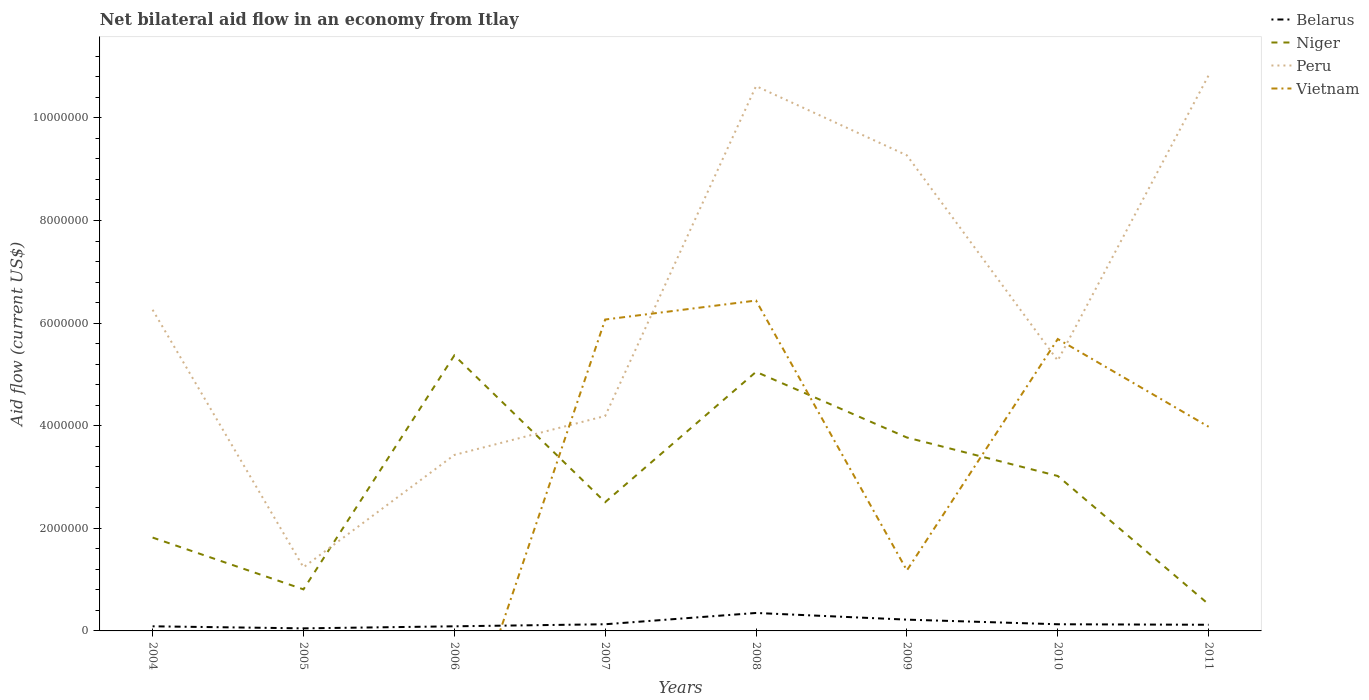How many different coloured lines are there?
Keep it short and to the point. 4. Across all years, what is the maximum net bilateral aid flow in Peru?
Your answer should be compact. 1.24e+06. What is the total net bilateral aid flow in Niger in the graph?
Give a very brief answer. -5.10e+05. What is the difference between the highest and the second highest net bilateral aid flow in Belarus?
Offer a terse response. 3.00e+05. Is the net bilateral aid flow in Peru strictly greater than the net bilateral aid flow in Belarus over the years?
Make the answer very short. No. How many years are there in the graph?
Ensure brevity in your answer.  8. What is the difference between two consecutive major ticks on the Y-axis?
Your response must be concise. 2.00e+06. Are the values on the major ticks of Y-axis written in scientific E-notation?
Provide a succinct answer. No. Does the graph contain any zero values?
Offer a very short reply. Yes. Where does the legend appear in the graph?
Give a very brief answer. Top right. How many legend labels are there?
Your response must be concise. 4. How are the legend labels stacked?
Your response must be concise. Vertical. What is the title of the graph?
Provide a short and direct response. Net bilateral aid flow in an economy from Itlay. What is the Aid flow (current US$) of Belarus in 2004?
Offer a terse response. 9.00e+04. What is the Aid flow (current US$) in Niger in 2004?
Give a very brief answer. 1.82e+06. What is the Aid flow (current US$) in Peru in 2004?
Offer a very short reply. 6.26e+06. What is the Aid flow (current US$) of Vietnam in 2004?
Offer a terse response. 0. What is the Aid flow (current US$) of Belarus in 2005?
Offer a very short reply. 5.00e+04. What is the Aid flow (current US$) in Niger in 2005?
Provide a succinct answer. 8.10e+05. What is the Aid flow (current US$) of Peru in 2005?
Make the answer very short. 1.24e+06. What is the Aid flow (current US$) in Belarus in 2006?
Provide a short and direct response. 9.00e+04. What is the Aid flow (current US$) in Niger in 2006?
Offer a very short reply. 5.37e+06. What is the Aid flow (current US$) in Peru in 2006?
Your answer should be very brief. 3.43e+06. What is the Aid flow (current US$) of Vietnam in 2006?
Provide a short and direct response. 0. What is the Aid flow (current US$) of Niger in 2007?
Keep it short and to the point. 2.51e+06. What is the Aid flow (current US$) of Peru in 2007?
Give a very brief answer. 4.19e+06. What is the Aid flow (current US$) in Vietnam in 2007?
Make the answer very short. 6.07e+06. What is the Aid flow (current US$) in Belarus in 2008?
Your answer should be compact. 3.50e+05. What is the Aid flow (current US$) in Niger in 2008?
Offer a very short reply. 5.05e+06. What is the Aid flow (current US$) in Peru in 2008?
Make the answer very short. 1.06e+07. What is the Aid flow (current US$) in Vietnam in 2008?
Ensure brevity in your answer.  6.44e+06. What is the Aid flow (current US$) of Belarus in 2009?
Your answer should be very brief. 2.20e+05. What is the Aid flow (current US$) in Niger in 2009?
Offer a terse response. 3.77e+06. What is the Aid flow (current US$) of Peru in 2009?
Your response must be concise. 9.27e+06. What is the Aid flow (current US$) in Vietnam in 2009?
Make the answer very short. 1.18e+06. What is the Aid flow (current US$) in Belarus in 2010?
Your response must be concise. 1.30e+05. What is the Aid flow (current US$) in Niger in 2010?
Give a very brief answer. 3.02e+06. What is the Aid flow (current US$) of Peru in 2010?
Your answer should be compact. 5.27e+06. What is the Aid flow (current US$) of Vietnam in 2010?
Provide a short and direct response. 5.69e+06. What is the Aid flow (current US$) in Niger in 2011?
Your response must be concise. 5.20e+05. What is the Aid flow (current US$) of Peru in 2011?
Your answer should be compact. 1.08e+07. What is the Aid flow (current US$) of Vietnam in 2011?
Your answer should be compact. 3.98e+06. Across all years, what is the maximum Aid flow (current US$) in Niger?
Your response must be concise. 5.37e+06. Across all years, what is the maximum Aid flow (current US$) in Peru?
Your response must be concise. 1.08e+07. Across all years, what is the maximum Aid flow (current US$) of Vietnam?
Make the answer very short. 6.44e+06. Across all years, what is the minimum Aid flow (current US$) in Belarus?
Keep it short and to the point. 5.00e+04. Across all years, what is the minimum Aid flow (current US$) in Niger?
Make the answer very short. 5.20e+05. Across all years, what is the minimum Aid flow (current US$) in Peru?
Your answer should be compact. 1.24e+06. Across all years, what is the minimum Aid flow (current US$) of Vietnam?
Give a very brief answer. 0. What is the total Aid flow (current US$) in Belarus in the graph?
Your answer should be compact. 1.18e+06. What is the total Aid flow (current US$) of Niger in the graph?
Offer a very short reply. 2.29e+07. What is the total Aid flow (current US$) of Peru in the graph?
Give a very brief answer. 5.11e+07. What is the total Aid flow (current US$) in Vietnam in the graph?
Your answer should be very brief. 2.34e+07. What is the difference between the Aid flow (current US$) of Belarus in 2004 and that in 2005?
Your answer should be very brief. 4.00e+04. What is the difference between the Aid flow (current US$) in Niger in 2004 and that in 2005?
Your answer should be very brief. 1.01e+06. What is the difference between the Aid flow (current US$) of Peru in 2004 and that in 2005?
Keep it short and to the point. 5.02e+06. What is the difference between the Aid flow (current US$) in Belarus in 2004 and that in 2006?
Offer a terse response. 0. What is the difference between the Aid flow (current US$) in Niger in 2004 and that in 2006?
Provide a succinct answer. -3.55e+06. What is the difference between the Aid flow (current US$) of Peru in 2004 and that in 2006?
Keep it short and to the point. 2.83e+06. What is the difference between the Aid flow (current US$) of Niger in 2004 and that in 2007?
Your answer should be very brief. -6.90e+05. What is the difference between the Aid flow (current US$) of Peru in 2004 and that in 2007?
Ensure brevity in your answer.  2.07e+06. What is the difference between the Aid flow (current US$) of Belarus in 2004 and that in 2008?
Make the answer very short. -2.60e+05. What is the difference between the Aid flow (current US$) in Niger in 2004 and that in 2008?
Offer a terse response. -3.23e+06. What is the difference between the Aid flow (current US$) of Peru in 2004 and that in 2008?
Ensure brevity in your answer.  -4.36e+06. What is the difference between the Aid flow (current US$) in Niger in 2004 and that in 2009?
Offer a very short reply. -1.95e+06. What is the difference between the Aid flow (current US$) of Peru in 2004 and that in 2009?
Keep it short and to the point. -3.01e+06. What is the difference between the Aid flow (current US$) of Belarus in 2004 and that in 2010?
Give a very brief answer. -4.00e+04. What is the difference between the Aid flow (current US$) in Niger in 2004 and that in 2010?
Your answer should be very brief. -1.20e+06. What is the difference between the Aid flow (current US$) in Peru in 2004 and that in 2010?
Give a very brief answer. 9.90e+05. What is the difference between the Aid flow (current US$) in Belarus in 2004 and that in 2011?
Your answer should be very brief. -3.00e+04. What is the difference between the Aid flow (current US$) of Niger in 2004 and that in 2011?
Give a very brief answer. 1.30e+06. What is the difference between the Aid flow (current US$) of Peru in 2004 and that in 2011?
Provide a short and direct response. -4.57e+06. What is the difference between the Aid flow (current US$) in Belarus in 2005 and that in 2006?
Offer a terse response. -4.00e+04. What is the difference between the Aid flow (current US$) in Niger in 2005 and that in 2006?
Your answer should be very brief. -4.56e+06. What is the difference between the Aid flow (current US$) in Peru in 2005 and that in 2006?
Give a very brief answer. -2.19e+06. What is the difference between the Aid flow (current US$) of Niger in 2005 and that in 2007?
Keep it short and to the point. -1.70e+06. What is the difference between the Aid flow (current US$) of Peru in 2005 and that in 2007?
Your response must be concise. -2.95e+06. What is the difference between the Aid flow (current US$) of Niger in 2005 and that in 2008?
Your answer should be compact. -4.24e+06. What is the difference between the Aid flow (current US$) in Peru in 2005 and that in 2008?
Make the answer very short. -9.38e+06. What is the difference between the Aid flow (current US$) of Niger in 2005 and that in 2009?
Offer a very short reply. -2.96e+06. What is the difference between the Aid flow (current US$) in Peru in 2005 and that in 2009?
Your answer should be very brief. -8.03e+06. What is the difference between the Aid flow (current US$) in Belarus in 2005 and that in 2010?
Provide a short and direct response. -8.00e+04. What is the difference between the Aid flow (current US$) in Niger in 2005 and that in 2010?
Offer a very short reply. -2.21e+06. What is the difference between the Aid flow (current US$) in Peru in 2005 and that in 2010?
Your answer should be compact. -4.03e+06. What is the difference between the Aid flow (current US$) in Belarus in 2005 and that in 2011?
Ensure brevity in your answer.  -7.00e+04. What is the difference between the Aid flow (current US$) in Niger in 2005 and that in 2011?
Make the answer very short. 2.90e+05. What is the difference between the Aid flow (current US$) of Peru in 2005 and that in 2011?
Offer a terse response. -9.59e+06. What is the difference between the Aid flow (current US$) of Belarus in 2006 and that in 2007?
Ensure brevity in your answer.  -4.00e+04. What is the difference between the Aid flow (current US$) of Niger in 2006 and that in 2007?
Your response must be concise. 2.86e+06. What is the difference between the Aid flow (current US$) in Peru in 2006 and that in 2007?
Your answer should be very brief. -7.60e+05. What is the difference between the Aid flow (current US$) in Peru in 2006 and that in 2008?
Ensure brevity in your answer.  -7.19e+06. What is the difference between the Aid flow (current US$) of Belarus in 2006 and that in 2009?
Offer a very short reply. -1.30e+05. What is the difference between the Aid flow (current US$) in Niger in 2006 and that in 2009?
Offer a terse response. 1.60e+06. What is the difference between the Aid flow (current US$) in Peru in 2006 and that in 2009?
Provide a short and direct response. -5.84e+06. What is the difference between the Aid flow (current US$) in Niger in 2006 and that in 2010?
Your response must be concise. 2.35e+06. What is the difference between the Aid flow (current US$) of Peru in 2006 and that in 2010?
Keep it short and to the point. -1.84e+06. What is the difference between the Aid flow (current US$) in Niger in 2006 and that in 2011?
Your response must be concise. 4.85e+06. What is the difference between the Aid flow (current US$) of Peru in 2006 and that in 2011?
Keep it short and to the point. -7.40e+06. What is the difference between the Aid flow (current US$) in Belarus in 2007 and that in 2008?
Your answer should be very brief. -2.20e+05. What is the difference between the Aid flow (current US$) in Niger in 2007 and that in 2008?
Provide a short and direct response. -2.54e+06. What is the difference between the Aid flow (current US$) in Peru in 2007 and that in 2008?
Your answer should be compact. -6.43e+06. What is the difference between the Aid flow (current US$) in Vietnam in 2007 and that in 2008?
Offer a very short reply. -3.70e+05. What is the difference between the Aid flow (current US$) in Niger in 2007 and that in 2009?
Your answer should be very brief. -1.26e+06. What is the difference between the Aid flow (current US$) of Peru in 2007 and that in 2009?
Offer a very short reply. -5.08e+06. What is the difference between the Aid flow (current US$) in Vietnam in 2007 and that in 2009?
Provide a succinct answer. 4.89e+06. What is the difference between the Aid flow (current US$) in Niger in 2007 and that in 2010?
Your response must be concise. -5.10e+05. What is the difference between the Aid flow (current US$) in Peru in 2007 and that in 2010?
Provide a short and direct response. -1.08e+06. What is the difference between the Aid flow (current US$) of Vietnam in 2007 and that in 2010?
Offer a very short reply. 3.80e+05. What is the difference between the Aid flow (current US$) of Belarus in 2007 and that in 2011?
Your response must be concise. 10000. What is the difference between the Aid flow (current US$) in Niger in 2007 and that in 2011?
Provide a succinct answer. 1.99e+06. What is the difference between the Aid flow (current US$) in Peru in 2007 and that in 2011?
Your response must be concise. -6.64e+06. What is the difference between the Aid flow (current US$) of Vietnam in 2007 and that in 2011?
Make the answer very short. 2.09e+06. What is the difference between the Aid flow (current US$) of Niger in 2008 and that in 2009?
Give a very brief answer. 1.28e+06. What is the difference between the Aid flow (current US$) in Peru in 2008 and that in 2009?
Offer a very short reply. 1.35e+06. What is the difference between the Aid flow (current US$) of Vietnam in 2008 and that in 2009?
Ensure brevity in your answer.  5.26e+06. What is the difference between the Aid flow (current US$) of Belarus in 2008 and that in 2010?
Offer a terse response. 2.20e+05. What is the difference between the Aid flow (current US$) of Niger in 2008 and that in 2010?
Ensure brevity in your answer.  2.03e+06. What is the difference between the Aid flow (current US$) in Peru in 2008 and that in 2010?
Your response must be concise. 5.35e+06. What is the difference between the Aid flow (current US$) in Vietnam in 2008 and that in 2010?
Keep it short and to the point. 7.50e+05. What is the difference between the Aid flow (current US$) of Niger in 2008 and that in 2011?
Ensure brevity in your answer.  4.53e+06. What is the difference between the Aid flow (current US$) in Peru in 2008 and that in 2011?
Your answer should be very brief. -2.10e+05. What is the difference between the Aid flow (current US$) of Vietnam in 2008 and that in 2011?
Offer a very short reply. 2.46e+06. What is the difference between the Aid flow (current US$) in Belarus in 2009 and that in 2010?
Offer a very short reply. 9.00e+04. What is the difference between the Aid flow (current US$) in Niger in 2009 and that in 2010?
Your answer should be very brief. 7.50e+05. What is the difference between the Aid flow (current US$) in Peru in 2009 and that in 2010?
Keep it short and to the point. 4.00e+06. What is the difference between the Aid flow (current US$) of Vietnam in 2009 and that in 2010?
Your response must be concise. -4.51e+06. What is the difference between the Aid flow (current US$) of Belarus in 2009 and that in 2011?
Ensure brevity in your answer.  1.00e+05. What is the difference between the Aid flow (current US$) in Niger in 2009 and that in 2011?
Make the answer very short. 3.25e+06. What is the difference between the Aid flow (current US$) of Peru in 2009 and that in 2011?
Make the answer very short. -1.56e+06. What is the difference between the Aid flow (current US$) in Vietnam in 2009 and that in 2011?
Provide a short and direct response. -2.80e+06. What is the difference between the Aid flow (current US$) in Belarus in 2010 and that in 2011?
Your response must be concise. 10000. What is the difference between the Aid flow (current US$) of Niger in 2010 and that in 2011?
Give a very brief answer. 2.50e+06. What is the difference between the Aid flow (current US$) of Peru in 2010 and that in 2011?
Offer a terse response. -5.56e+06. What is the difference between the Aid flow (current US$) of Vietnam in 2010 and that in 2011?
Offer a terse response. 1.71e+06. What is the difference between the Aid flow (current US$) of Belarus in 2004 and the Aid flow (current US$) of Niger in 2005?
Provide a succinct answer. -7.20e+05. What is the difference between the Aid flow (current US$) of Belarus in 2004 and the Aid flow (current US$) of Peru in 2005?
Your answer should be very brief. -1.15e+06. What is the difference between the Aid flow (current US$) of Niger in 2004 and the Aid flow (current US$) of Peru in 2005?
Your response must be concise. 5.80e+05. What is the difference between the Aid flow (current US$) in Belarus in 2004 and the Aid flow (current US$) in Niger in 2006?
Give a very brief answer. -5.28e+06. What is the difference between the Aid flow (current US$) in Belarus in 2004 and the Aid flow (current US$) in Peru in 2006?
Provide a short and direct response. -3.34e+06. What is the difference between the Aid flow (current US$) in Niger in 2004 and the Aid flow (current US$) in Peru in 2006?
Make the answer very short. -1.61e+06. What is the difference between the Aid flow (current US$) in Belarus in 2004 and the Aid flow (current US$) in Niger in 2007?
Provide a short and direct response. -2.42e+06. What is the difference between the Aid flow (current US$) of Belarus in 2004 and the Aid flow (current US$) of Peru in 2007?
Your response must be concise. -4.10e+06. What is the difference between the Aid flow (current US$) of Belarus in 2004 and the Aid flow (current US$) of Vietnam in 2007?
Make the answer very short. -5.98e+06. What is the difference between the Aid flow (current US$) of Niger in 2004 and the Aid flow (current US$) of Peru in 2007?
Give a very brief answer. -2.37e+06. What is the difference between the Aid flow (current US$) in Niger in 2004 and the Aid flow (current US$) in Vietnam in 2007?
Give a very brief answer. -4.25e+06. What is the difference between the Aid flow (current US$) of Peru in 2004 and the Aid flow (current US$) of Vietnam in 2007?
Offer a very short reply. 1.90e+05. What is the difference between the Aid flow (current US$) of Belarus in 2004 and the Aid flow (current US$) of Niger in 2008?
Keep it short and to the point. -4.96e+06. What is the difference between the Aid flow (current US$) of Belarus in 2004 and the Aid flow (current US$) of Peru in 2008?
Provide a short and direct response. -1.05e+07. What is the difference between the Aid flow (current US$) in Belarus in 2004 and the Aid flow (current US$) in Vietnam in 2008?
Your answer should be compact. -6.35e+06. What is the difference between the Aid flow (current US$) in Niger in 2004 and the Aid flow (current US$) in Peru in 2008?
Make the answer very short. -8.80e+06. What is the difference between the Aid flow (current US$) in Niger in 2004 and the Aid flow (current US$) in Vietnam in 2008?
Provide a succinct answer. -4.62e+06. What is the difference between the Aid flow (current US$) of Peru in 2004 and the Aid flow (current US$) of Vietnam in 2008?
Provide a short and direct response. -1.80e+05. What is the difference between the Aid flow (current US$) of Belarus in 2004 and the Aid flow (current US$) of Niger in 2009?
Make the answer very short. -3.68e+06. What is the difference between the Aid flow (current US$) of Belarus in 2004 and the Aid flow (current US$) of Peru in 2009?
Keep it short and to the point. -9.18e+06. What is the difference between the Aid flow (current US$) of Belarus in 2004 and the Aid flow (current US$) of Vietnam in 2009?
Your response must be concise. -1.09e+06. What is the difference between the Aid flow (current US$) in Niger in 2004 and the Aid flow (current US$) in Peru in 2009?
Make the answer very short. -7.45e+06. What is the difference between the Aid flow (current US$) of Niger in 2004 and the Aid flow (current US$) of Vietnam in 2009?
Your response must be concise. 6.40e+05. What is the difference between the Aid flow (current US$) in Peru in 2004 and the Aid flow (current US$) in Vietnam in 2009?
Provide a short and direct response. 5.08e+06. What is the difference between the Aid flow (current US$) in Belarus in 2004 and the Aid flow (current US$) in Niger in 2010?
Your answer should be compact. -2.93e+06. What is the difference between the Aid flow (current US$) of Belarus in 2004 and the Aid flow (current US$) of Peru in 2010?
Offer a terse response. -5.18e+06. What is the difference between the Aid flow (current US$) of Belarus in 2004 and the Aid flow (current US$) of Vietnam in 2010?
Offer a very short reply. -5.60e+06. What is the difference between the Aid flow (current US$) of Niger in 2004 and the Aid flow (current US$) of Peru in 2010?
Provide a short and direct response. -3.45e+06. What is the difference between the Aid flow (current US$) in Niger in 2004 and the Aid flow (current US$) in Vietnam in 2010?
Your response must be concise. -3.87e+06. What is the difference between the Aid flow (current US$) of Peru in 2004 and the Aid flow (current US$) of Vietnam in 2010?
Ensure brevity in your answer.  5.70e+05. What is the difference between the Aid flow (current US$) in Belarus in 2004 and the Aid flow (current US$) in Niger in 2011?
Provide a short and direct response. -4.30e+05. What is the difference between the Aid flow (current US$) of Belarus in 2004 and the Aid flow (current US$) of Peru in 2011?
Make the answer very short. -1.07e+07. What is the difference between the Aid flow (current US$) in Belarus in 2004 and the Aid flow (current US$) in Vietnam in 2011?
Provide a succinct answer. -3.89e+06. What is the difference between the Aid flow (current US$) of Niger in 2004 and the Aid flow (current US$) of Peru in 2011?
Give a very brief answer. -9.01e+06. What is the difference between the Aid flow (current US$) of Niger in 2004 and the Aid flow (current US$) of Vietnam in 2011?
Your answer should be compact. -2.16e+06. What is the difference between the Aid flow (current US$) in Peru in 2004 and the Aid flow (current US$) in Vietnam in 2011?
Give a very brief answer. 2.28e+06. What is the difference between the Aid flow (current US$) in Belarus in 2005 and the Aid flow (current US$) in Niger in 2006?
Make the answer very short. -5.32e+06. What is the difference between the Aid flow (current US$) of Belarus in 2005 and the Aid flow (current US$) of Peru in 2006?
Keep it short and to the point. -3.38e+06. What is the difference between the Aid flow (current US$) in Niger in 2005 and the Aid flow (current US$) in Peru in 2006?
Keep it short and to the point. -2.62e+06. What is the difference between the Aid flow (current US$) of Belarus in 2005 and the Aid flow (current US$) of Niger in 2007?
Your answer should be compact. -2.46e+06. What is the difference between the Aid flow (current US$) of Belarus in 2005 and the Aid flow (current US$) of Peru in 2007?
Provide a short and direct response. -4.14e+06. What is the difference between the Aid flow (current US$) in Belarus in 2005 and the Aid flow (current US$) in Vietnam in 2007?
Give a very brief answer. -6.02e+06. What is the difference between the Aid flow (current US$) of Niger in 2005 and the Aid flow (current US$) of Peru in 2007?
Ensure brevity in your answer.  -3.38e+06. What is the difference between the Aid flow (current US$) of Niger in 2005 and the Aid flow (current US$) of Vietnam in 2007?
Give a very brief answer. -5.26e+06. What is the difference between the Aid flow (current US$) of Peru in 2005 and the Aid flow (current US$) of Vietnam in 2007?
Provide a short and direct response. -4.83e+06. What is the difference between the Aid flow (current US$) in Belarus in 2005 and the Aid flow (current US$) in Niger in 2008?
Give a very brief answer. -5.00e+06. What is the difference between the Aid flow (current US$) of Belarus in 2005 and the Aid flow (current US$) of Peru in 2008?
Your answer should be very brief. -1.06e+07. What is the difference between the Aid flow (current US$) of Belarus in 2005 and the Aid flow (current US$) of Vietnam in 2008?
Your response must be concise. -6.39e+06. What is the difference between the Aid flow (current US$) in Niger in 2005 and the Aid flow (current US$) in Peru in 2008?
Offer a terse response. -9.81e+06. What is the difference between the Aid flow (current US$) of Niger in 2005 and the Aid flow (current US$) of Vietnam in 2008?
Provide a succinct answer. -5.63e+06. What is the difference between the Aid flow (current US$) of Peru in 2005 and the Aid flow (current US$) of Vietnam in 2008?
Offer a very short reply. -5.20e+06. What is the difference between the Aid flow (current US$) of Belarus in 2005 and the Aid flow (current US$) of Niger in 2009?
Make the answer very short. -3.72e+06. What is the difference between the Aid flow (current US$) of Belarus in 2005 and the Aid flow (current US$) of Peru in 2009?
Offer a terse response. -9.22e+06. What is the difference between the Aid flow (current US$) in Belarus in 2005 and the Aid flow (current US$) in Vietnam in 2009?
Provide a short and direct response. -1.13e+06. What is the difference between the Aid flow (current US$) in Niger in 2005 and the Aid flow (current US$) in Peru in 2009?
Offer a terse response. -8.46e+06. What is the difference between the Aid flow (current US$) in Niger in 2005 and the Aid flow (current US$) in Vietnam in 2009?
Offer a terse response. -3.70e+05. What is the difference between the Aid flow (current US$) in Belarus in 2005 and the Aid flow (current US$) in Niger in 2010?
Provide a succinct answer. -2.97e+06. What is the difference between the Aid flow (current US$) in Belarus in 2005 and the Aid flow (current US$) in Peru in 2010?
Give a very brief answer. -5.22e+06. What is the difference between the Aid flow (current US$) of Belarus in 2005 and the Aid flow (current US$) of Vietnam in 2010?
Provide a succinct answer. -5.64e+06. What is the difference between the Aid flow (current US$) of Niger in 2005 and the Aid flow (current US$) of Peru in 2010?
Provide a short and direct response. -4.46e+06. What is the difference between the Aid flow (current US$) of Niger in 2005 and the Aid flow (current US$) of Vietnam in 2010?
Keep it short and to the point. -4.88e+06. What is the difference between the Aid flow (current US$) of Peru in 2005 and the Aid flow (current US$) of Vietnam in 2010?
Make the answer very short. -4.45e+06. What is the difference between the Aid flow (current US$) of Belarus in 2005 and the Aid flow (current US$) of Niger in 2011?
Your answer should be compact. -4.70e+05. What is the difference between the Aid flow (current US$) of Belarus in 2005 and the Aid flow (current US$) of Peru in 2011?
Offer a very short reply. -1.08e+07. What is the difference between the Aid flow (current US$) in Belarus in 2005 and the Aid flow (current US$) in Vietnam in 2011?
Give a very brief answer. -3.93e+06. What is the difference between the Aid flow (current US$) of Niger in 2005 and the Aid flow (current US$) of Peru in 2011?
Give a very brief answer. -1.00e+07. What is the difference between the Aid flow (current US$) in Niger in 2005 and the Aid flow (current US$) in Vietnam in 2011?
Your answer should be compact. -3.17e+06. What is the difference between the Aid flow (current US$) of Peru in 2005 and the Aid flow (current US$) of Vietnam in 2011?
Give a very brief answer. -2.74e+06. What is the difference between the Aid flow (current US$) of Belarus in 2006 and the Aid flow (current US$) of Niger in 2007?
Ensure brevity in your answer.  -2.42e+06. What is the difference between the Aid flow (current US$) of Belarus in 2006 and the Aid flow (current US$) of Peru in 2007?
Make the answer very short. -4.10e+06. What is the difference between the Aid flow (current US$) of Belarus in 2006 and the Aid flow (current US$) of Vietnam in 2007?
Ensure brevity in your answer.  -5.98e+06. What is the difference between the Aid flow (current US$) of Niger in 2006 and the Aid flow (current US$) of Peru in 2007?
Provide a succinct answer. 1.18e+06. What is the difference between the Aid flow (current US$) in Niger in 2006 and the Aid flow (current US$) in Vietnam in 2007?
Give a very brief answer. -7.00e+05. What is the difference between the Aid flow (current US$) in Peru in 2006 and the Aid flow (current US$) in Vietnam in 2007?
Offer a terse response. -2.64e+06. What is the difference between the Aid flow (current US$) in Belarus in 2006 and the Aid flow (current US$) in Niger in 2008?
Offer a very short reply. -4.96e+06. What is the difference between the Aid flow (current US$) in Belarus in 2006 and the Aid flow (current US$) in Peru in 2008?
Provide a short and direct response. -1.05e+07. What is the difference between the Aid flow (current US$) of Belarus in 2006 and the Aid flow (current US$) of Vietnam in 2008?
Keep it short and to the point. -6.35e+06. What is the difference between the Aid flow (current US$) in Niger in 2006 and the Aid flow (current US$) in Peru in 2008?
Your answer should be very brief. -5.25e+06. What is the difference between the Aid flow (current US$) in Niger in 2006 and the Aid flow (current US$) in Vietnam in 2008?
Your answer should be very brief. -1.07e+06. What is the difference between the Aid flow (current US$) in Peru in 2006 and the Aid flow (current US$) in Vietnam in 2008?
Your answer should be compact. -3.01e+06. What is the difference between the Aid flow (current US$) in Belarus in 2006 and the Aid flow (current US$) in Niger in 2009?
Offer a terse response. -3.68e+06. What is the difference between the Aid flow (current US$) in Belarus in 2006 and the Aid flow (current US$) in Peru in 2009?
Keep it short and to the point. -9.18e+06. What is the difference between the Aid flow (current US$) in Belarus in 2006 and the Aid flow (current US$) in Vietnam in 2009?
Keep it short and to the point. -1.09e+06. What is the difference between the Aid flow (current US$) of Niger in 2006 and the Aid flow (current US$) of Peru in 2009?
Offer a very short reply. -3.90e+06. What is the difference between the Aid flow (current US$) in Niger in 2006 and the Aid flow (current US$) in Vietnam in 2009?
Give a very brief answer. 4.19e+06. What is the difference between the Aid flow (current US$) in Peru in 2006 and the Aid flow (current US$) in Vietnam in 2009?
Your answer should be compact. 2.25e+06. What is the difference between the Aid flow (current US$) of Belarus in 2006 and the Aid flow (current US$) of Niger in 2010?
Keep it short and to the point. -2.93e+06. What is the difference between the Aid flow (current US$) of Belarus in 2006 and the Aid flow (current US$) of Peru in 2010?
Your response must be concise. -5.18e+06. What is the difference between the Aid flow (current US$) in Belarus in 2006 and the Aid flow (current US$) in Vietnam in 2010?
Your answer should be very brief. -5.60e+06. What is the difference between the Aid flow (current US$) in Niger in 2006 and the Aid flow (current US$) in Peru in 2010?
Keep it short and to the point. 1.00e+05. What is the difference between the Aid flow (current US$) of Niger in 2006 and the Aid flow (current US$) of Vietnam in 2010?
Offer a terse response. -3.20e+05. What is the difference between the Aid flow (current US$) of Peru in 2006 and the Aid flow (current US$) of Vietnam in 2010?
Your response must be concise. -2.26e+06. What is the difference between the Aid flow (current US$) of Belarus in 2006 and the Aid flow (current US$) of Niger in 2011?
Your response must be concise. -4.30e+05. What is the difference between the Aid flow (current US$) of Belarus in 2006 and the Aid flow (current US$) of Peru in 2011?
Offer a very short reply. -1.07e+07. What is the difference between the Aid flow (current US$) of Belarus in 2006 and the Aid flow (current US$) of Vietnam in 2011?
Offer a terse response. -3.89e+06. What is the difference between the Aid flow (current US$) in Niger in 2006 and the Aid flow (current US$) in Peru in 2011?
Keep it short and to the point. -5.46e+06. What is the difference between the Aid flow (current US$) in Niger in 2006 and the Aid flow (current US$) in Vietnam in 2011?
Give a very brief answer. 1.39e+06. What is the difference between the Aid flow (current US$) of Peru in 2006 and the Aid flow (current US$) of Vietnam in 2011?
Provide a succinct answer. -5.50e+05. What is the difference between the Aid flow (current US$) in Belarus in 2007 and the Aid flow (current US$) in Niger in 2008?
Offer a very short reply. -4.92e+06. What is the difference between the Aid flow (current US$) of Belarus in 2007 and the Aid flow (current US$) of Peru in 2008?
Ensure brevity in your answer.  -1.05e+07. What is the difference between the Aid flow (current US$) of Belarus in 2007 and the Aid flow (current US$) of Vietnam in 2008?
Give a very brief answer. -6.31e+06. What is the difference between the Aid flow (current US$) of Niger in 2007 and the Aid flow (current US$) of Peru in 2008?
Keep it short and to the point. -8.11e+06. What is the difference between the Aid flow (current US$) of Niger in 2007 and the Aid flow (current US$) of Vietnam in 2008?
Provide a succinct answer. -3.93e+06. What is the difference between the Aid flow (current US$) of Peru in 2007 and the Aid flow (current US$) of Vietnam in 2008?
Provide a succinct answer. -2.25e+06. What is the difference between the Aid flow (current US$) of Belarus in 2007 and the Aid flow (current US$) of Niger in 2009?
Your answer should be compact. -3.64e+06. What is the difference between the Aid flow (current US$) of Belarus in 2007 and the Aid flow (current US$) of Peru in 2009?
Keep it short and to the point. -9.14e+06. What is the difference between the Aid flow (current US$) in Belarus in 2007 and the Aid flow (current US$) in Vietnam in 2009?
Provide a succinct answer. -1.05e+06. What is the difference between the Aid flow (current US$) of Niger in 2007 and the Aid flow (current US$) of Peru in 2009?
Your answer should be very brief. -6.76e+06. What is the difference between the Aid flow (current US$) in Niger in 2007 and the Aid flow (current US$) in Vietnam in 2009?
Make the answer very short. 1.33e+06. What is the difference between the Aid flow (current US$) in Peru in 2007 and the Aid flow (current US$) in Vietnam in 2009?
Provide a succinct answer. 3.01e+06. What is the difference between the Aid flow (current US$) of Belarus in 2007 and the Aid flow (current US$) of Niger in 2010?
Provide a succinct answer. -2.89e+06. What is the difference between the Aid flow (current US$) of Belarus in 2007 and the Aid flow (current US$) of Peru in 2010?
Make the answer very short. -5.14e+06. What is the difference between the Aid flow (current US$) of Belarus in 2007 and the Aid flow (current US$) of Vietnam in 2010?
Offer a terse response. -5.56e+06. What is the difference between the Aid flow (current US$) of Niger in 2007 and the Aid flow (current US$) of Peru in 2010?
Provide a short and direct response. -2.76e+06. What is the difference between the Aid flow (current US$) in Niger in 2007 and the Aid flow (current US$) in Vietnam in 2010?
Give a very brief answer. -3.18e+06. What is the difference between the Aid flow (current US$) in Peru in 2007 and the Aid flow (current US$) in Vietnam in 2010?
Give a very brief answer. -1.50e+06. What is the difference between the Aid flow (current US$) in Belarus in 2007 and the Aid flow (current US$) in Niger in 2011?
Ensure brevity in your answer.  -3.90e+05. What is the difference between the Aid flow (current US$) of Belarus in 2007 and the Aid flow (current US$) of Peru in 2011?
Keep it short and to the point. -1.07e+07. What is the difference between the Aid flow (current US$) of Belarus in 2007 and the Aid flow (current US$) of Vietnam in 2011?
Your answer should be compact. -3.85e+06. What is the difference between the Aid flow (current US$) of Niger in 2007 and the Aid flow (current US$) of Peru in 2011?
Offer a very short reply. -8.32e+06. What is the difference between the Aid flow (current US$) of Niger in 2007 and the Aid flow (current US$) of Vietnam in 2011?
Provide a succinct answer. -1.47e+06. What is the difference between the Aid flow (current US$) of Belarus in 2008 and the Aid flow (current US$) of Niger in 2009?
Give a very brief answer. -3.42e+06. What is the difference between the Aid flow (current US$) of Belarus in 2008 and the Aid flow (current US$) of Peru in 2009?
Make the answer very short. -8.92e+06. What is the difference between the Aid flow (current US$) of Belarus in 2008 and the Aid flow (current US$) of Vietnam in 2009?
Ensure brevity in your answer.  -8.30e+05. What is the difference between the Aid flow (current US$) in Niger in 2008 and the Aid flow (current US$) in Peru in 2009?
Provide a short and direct response. -4.22e+06. What is the difference between the Aid flow (current US$) in Niger in 2008 and the Aid flow (current US$) in Vietnam in 2009?
Give a very brief answer. 3.87e+06. What is the difference between the Aid flow (current US$) of Peru in 2008 and the Aid flow (current US$) of Vietnam in 2009?
Provide a succinct answer. 9.44e+06. What is the difference between the Aid flow (current US$) in Belarus in 2008 and the Aid flow (current US$) in Niger in 2010?
Provide a short and direct response. -2.67e+06. What is the difference between the Aid flow (current US$) in Belarus in 2008 and the Aid flow (current US$) in Peru in 2010?
Make the answer very short. -4.92e+06. What is the difference between the Aid flow (current US$) of Belarus in 2008 and the Aid flow (current US$) of Vietnam in 2010?
Provide a short and direct response. -5.34e+06. What is the difference between the Aid flow (current US$) of Niger in 2008 and the Aid flow (current US$) of Vietnam in 2010?
Give a very brief answer. -6.40e+05. What is the difference between the Aid flow (current US$) in Peru in 2008 and the Aid flow (current US$) in Vietnam in 2010?
Give a very brief answer. 4.93e+06. What is the difference between the Aid flow (current US$) of Belarus in 2008 and the Aid flow (current US$) of Peru in 2011?
Make the answer very short. -1.05e+07. What is the difference between the Aid flow (current US$) in Belarus in 2008 and the Aid flow (current US$) in Vietnam in 2011?
Offer a terse response. -3.63e+06. What is the difference between the Aid flow (current US$) in Niger in 2008 and the Aid flow (current US$) in Peru in 2011?
Give a very brief answer. -5.78e+06. What is the difference between the Aid flow (current US$) in Niger in 2008 and the Aid flow (current US$) in Vietnam in 2011?
Ensure brevity in your answer.  1.07e+06. What is the difference between the Aid flow (current US$) of Peru in 2008 and the Aid flow (current US$) of Vietnam in 2011?
Make the answer very short. 6.64e+06. What is the difference between the Aid flow (current US$) of Belarus in 2009 and the Aid flow (current US$) of Niger in 2010?
Offer a very short reply. -2.80e+06. What is the difference between the Aid flow (current US$) in Belarus in 2009 and the Aid flow (current US$) in Peru in 2010?
Provide a succinct answer. -5.05e+06. What is the difference between the Aid flow (current US$) in Belarus in 2009 and the Aid flow (current US$) in Vietnam in 2010?
Your response must be concise. -5.47e+06. What is the difference between the Aid flow (current US$) in Niger in 2009 and the Aid flow (current US$) in Peru in 2010?
Offer a very short reply. -1.50e+06. What is the difference between the Aid flow (current US$) in Niger in 2009 and the Aid flow (current US$) in Vietnam in 2010?
Make the answer very short. -1.92e+06. What is the difference between the Aid flow (current US$) in Peru in 2009 and the Aid flow (current US$) in Vietnam in 2010?
Offer a terse response. 3.58e+06. What is the difference between the Aid flow (current US$) of Belarus in 2009 and the Aid flow (current US$) of Peru in 2011?
Offer a very short reply. -1.06e+07. What is the difference between the Aid flow (current US$) in Belarus in 2009 and the Aid flow (current US$) in Vietnam in 2011?
Provide a succinct answer. -3.76e+06. What is the difference between the Aid flow (current US$) of Niger in 2009 and the Aid flow (current US$) of Peru in 2011?
Provide a succinct answer. -7.06e+06. What is the difference between the Aid flow (current US$) in Niger in 2009 and the Aid flow (current US$) in Vietnam in 2011?
Offer a terse response. -2.10e+05. What is the difference between the Aid flow (current US$) in Peru in 2009 and the Aid flow (current US$) in Vietnam in 2011?
Offer a terse response. 5.29e+06. What is the difference between the Aid flow (current US$) of Belarus in 2010 and the Aid flow (current US$) of Niger in 2011?
Your answer should be very brief. -3.90e+05. What is the difference between the Aid flow (current US$) of Belarus in 2010 and the Aid flow (current US$) of Peru in 2011?
Ensure brevity in your answer.  -1.07e+07. What is the difference between the Aid flow (current US$) in Belarus in 2010 and the Aid flow (current US$) in Vietnam in 2011?
Provide a short and direct response. -3.85e+06. What is the difference between the Aid flow (current US$) of Niger in 2010 and the Aid flow (current US$) of Peru in 2011?
Provide a succinct answer. -7.81e+06. What is the difference between the Aid flow (current US$) of Niger in 2010 and the Aid flow (current US$) of Vietnam in 2011?
Provide a short and direct response. -9.60e+05. What is the difference between the Aid flow (current US$) of Peru in 2010 and the Aid flow (current US$) of Vietnam in 2011?
Offer a terse response. 1.29e+06. What is the average Aid flow (current US$) of Belarus per year?
Make the answer very short. 1.48e+05. What is the average Aid flow (current US$) of Niger per year?
Give a very brief answer. 2.86e+06. What is the average Aid flow (current US$) of Peru per year?
Provide a short and direct response. 6.39e+06. What is the average Aid flow (current US$) in Vietnam per year?
Give a very brief answer. 2.92e+06. In the year 2004, what is the difference between the Aid flow (current US$) of Belarus and Aid flow (current US$) of Niger?
Provide a succinct answer. -1.73e+06. In the year 2004, what is the difference between the Aid flow (current US$) of Belarus and Aid flow (current US$) of Peru?
Your response must be concise. -6.17e+06. In the year 2004, what is the difference between the Aid flow (current US$) in Niger and Aid flow (current US$) in Peru?
Provide a succinct answer. -4.44e+06. In the year 2005, what is the difference between the Aid flow (current US$) in Belarus and Aid flow (current US$) in Niger?
Your answer should be compact. -7.60e+05. In the year 2005, what is the difference between the Aid flow (current US$) of Belarus and Aid flow (current US$) of Peru?
Keep it short and to the point. -1.19e+06. In the year 2005, what is the difference between the Aid flow (current US$) of Niger and Aid flow (current US$) of Peru?
Offer a terse response. -4.30e+05. In the year 2006, what is the difference between the Aid flow (current US$) in Belarus and Aid flow (current US$) in Niger?
Provide a succinct answer. -5.28e+06. In the year 2006, what is the difference between the Aid flow (current US$) of Belarus and Aid flow (current US$) of Peru?
Ensure brevity in your answer.  -3.34e+06. In the year 2006, what is the difference between the Aid flow (current US$) of Niger and Aid flow (current US$) of Peru?
Give a very brief answer. 1.94e+06. In the year 2007, what is the difference between the Aid flow (current US$) in Belarus and Aid flow (current US$) in Niger?
Your answer should be compact. -2.38e+06. In the year 2007, what is the difference between the Aid flow (current US$) in Belarus and Aid flow (current US$) in Peru?
Ensure brevity in your answer.  -4.06e+06. In the year 2007, what is the difference between the Aid flow (current US$) of Belarus and Aid flow (current US$) of Vietnam?
Your answer should be compact. -5.94e+06. In the year 2007, what is the difference between the Aid flow (current US$) in Niger and Aid flow (current US$) in Peru?
Your response must be concise. -1.68e+06. In the year 2007, what is the difference between the Aid flow (current US$) of Niger and Aid flow (current US$) of Vietnam?
Offer a very short reply. -3.56e+06. In the year 2007, what is the difference between the Aid flow (current US$) in Peru and Aid flow (current US$) in Vietnam?
Your answer should be very brief. -1.88e+06. In the year 2008, what is the difference between the Aid flow (current US$) in Belarus and Aid flow (current US$) in Niger?
Make the answer very short. -4.70e+06. In the year 2008, what is the difference between the Aid flow (current US$) in Belarus and Aid flow (current US$) in Peru?
Provide a succinct answer. -1.03e+07. In the year 2008, what is the difference between the Aid flow (current US$) of Belarus and Aid flow (current US$) of Vietnam?
Your answer should be very brief. -6.09e+06. In the year 2008, what is the difference between the Aid flow (current US$) of Niger and Aid flow (current US$) of Peru?
Make the answer very short. -5.57e+06. In the year 2008, what is the difference between the Aid flow (current US$) of Niger and Aid flow (current US$) of Vietnam?
Your answer should be very brief. -1.39e+06. In the year 2008, what is the difference between the Aid flow (current US$) in Peru and Aid flow (current US$) in Vietnam?
Provide a succinct answer. 4.18e+06. In the year 2009, what is the difference between the Aid flow (current US$) of Belarus and Aid flow (current US$) of Niger?
Offer a very short reply. -3.55e+06. In the year 2009, what is the difference between the Aid flow (current US$) in Belarus and Aid flow (current US$) in Peru?
Ensure brevity in your answer.  -9.05e+06. In the year 2009, what is the difference between the Aid flow (current US$) of Belarus and Aid flow (current US$) of Vietnam?
Offer a terse response. -9.60e+05. In the year 2009, what is the difference between the Aid flow (current US$) of Niger and Aid flow (current US$) of Peru?
Provide a short and direct response. -5.50e+06. In the year 2009, what is the difference between the Aid flow (current US$) of Niger and Aid flow (current US$) of Vietnam?
Offer a very short reply. 2.59e+06. In the year 2009, what is the difference between the Aid flow (current US$) of Peru and Aid flow (current US$) of Vietnam?
Make the answer very short. 8.09e+06. In the year 2010, what is the difference between the Aid flow (current US$) of Belarus and Aid flow (current US$) of Niger?
Give a very brief answer. -2.89e+06. In the year 2010, what is the difference between the Aid flow (current US$) of Belarus and Aid flow (current US$) of Peru?
Keep it short and to the point. -5.14e+06. In the year 2010, what is the difference between the Aid flow (current US$) in Belarus and Aid flow (current US$) in Vietnam?
Your response must be concise. -5.56e+06. In the year 2010, what is the difference between the Aid flow (current US$) of Niger and Aid flow (current US$) of Peru?
Give a very brief answer. -2.25e+06. In the year 2010, what is the difference between the Aid flow (current US$) in Niger and Aid flow (current US$) in Vietnam?
Make the answer very short. -2.67e+06. In the year 2010, what is the difference between the Aid flow (current US$) of Peru and Aid flow (current US$) of Vietnam?
Ensure brevity in your answer.  -4.20e+05. In the year 2011, what is the difference between the Aid flow (current US$) in Belarus and Aid flow (current US$) in Niger?
Your response must be concise. -4.00e+05. In the year 2011, what is the difference between the Aid flow (current US$) in Belarus and Aid flow (current US$) in Peru?
Make the answer very short. -1.07e+07. In the year 2011, what is the difference between the Aid flow (current US$) of Belarus and Aid flow (current US$) of Vietnam?
Provide a short and direct response. -3.86e+06. In the year 2011, what is the difference between the Aid flow (current US$) in Niger and Aid flow (current US$) in Peru?
Provide a short and direct response. -1.03e+07. In the year 2011, what is the difference between the Aid flow (current US$) in Niger and Aid flow (current US$) in Vietnam?
Your response must be concise. -3.46e+06. In the year 2011, what is the difference between the Aid flow (current US$) of Peru and Aid flow (current US$) of Vietnam?
Give a very brief answer. 6.85e+06. What is the ratio of the Aid flow (current US$) of Niger in 2004 to that in 2005?
Provide a succinct answer. 2.25. What is the ratio of the Aid flow (current US$) of Peru in 2004 to that in 2005?
Provide a succinct answer. 5.05. What is the ratio of the Aid flow (current US$) of Niger in 2004 to that in 2006?
Offer a terse response. 0.34. What is the ratio of the Aid flow (current US$) of Peru in 2004 to that in 2006?
Make the answer very short. 1.83. What is the ratio of the Aid flow (current US$) of Belarus in 2004 to that in 2007?
Give a very brief answer. 0.69. What is the ratio of the Aid flow (current US$) in Niger in 2004 to that in 2007?
Give a very brief answer. 0.73. What is the ratio of the Aid flow (current US$) of Peru in 2004 to that in 2007?
Your answer should be compact. 1.49. What is the ratio of the Aid flow (current US$) in Belarus in 2004 to that in 2008?
Ensure brevity in your answer.  0.26. What is the ratio of the Aid flow (current US$) in Niger in 2004 to that in 2008?
Make the answer very short. 0.36. What is the ratio of the Aid flow (current US$) of Peru in 2004 to that in 2008?
Ensure brevity in your answer.  0.59. What is the ratio of the Aid flow (current US$) of Belarus in 2004 to that in 2009?
Your answer should be very brief. 0.41. What is the ratio of the Aid flow (current US$) of Niger in 2004 to that in 2009?
Provide a succinct answer. 0.48. What is the ratio of the Aid flow (current US$) in Peru in 2004 to that in 2009?
Offer a terse response. 0.68. What is the ratio of the Aid flow (current US$) of Belarus in 2004 to that in 2010?
Your answer should be compact. 0.69. What is the ratio of the Aid flow (current US$) in Niger in 2004 to that in 2010?
Make the answer very short. 0.6. What is the ratio of the Aid flow (current US$) in Peru in 2004 to that in 2010?
Offer a terse response. 1.19. What is the ratio of the Aid flow (current US$) of Niger in 2004 to that in 2011?
Provide a short and direct response. 3.5. What is the ratio of the Aid flow (current US$) in Peru in 2004 to that in 2011?
Your answer should be compact. 0.58. What is the ratio of the Aid flow (current US$) of Belarus in 2005 to that in 2006?
Offer a very short reply. 0.56. What is the ratio of the Aid flow (current US$) of Niger in 2005 to that in 2006?
Offer a very short reply. 0.15. What is the ratio of the Aid flow (current US$) of Peru in 2005 to that in 2006?
Ensure brevity in your answer.  0.36. What is the ratio of the Aid flow (current US$) of Belarus in 2005 to that in 2007?
Give a very brief answer. 0.38. What is the ratio of the Aid flow (current US$) of Niger in 2005 to that in 2007?
Provide a succinct answer. 0.32. What is the ratio of the Aid flow (current US$) of Peru in 2005 to that in 2007?
Give a very brief answer. 0.3. What is the ratio of the Aid flow (current US$) of Belarus in 2005 to that in 2008?
Make the answer very short. 0.14. What is the ratio of the Aid flow (current US$) of Niger in 2005 to that in 2008?
Ensure brevity in your answer.  0.16. What is the ratio of the Aid flow (current US$) in Peru in 2005 to that in 2008?
Offer a very short reply. 0.12. What is the ratio of the Aid flow (current US$) in Belarus in 2005 to that in 2009?
Give a very brief answer. 0.23. What is the ratio of the Aid flow (current US$) of Niger in 2005 to that in 2009?
Your answer should be compact. 0.21. What is the ratio of the Aid flow (current US$) of Peru in 2005 to that in 2009?
Keep it short and to the point. 0.13. What is the ratio of the Aid flow (current US$) of Belarus in 2005 to that in 2010?
Keep it short and to the point. 0.38. What is the ratio of the Aid flow (current US$) of Niger in 2005 to that in 2010?
Your answer should be very brief. 0.27. What is the ratio of the Aid flow (current US$) in Peru in 2005 to that in 2010?
Give a very brief answer. 0.24. What is the ratio of the Aid flow (current US$) of Belarus in 2005 to that in 2011?
Your response must be concise. 0.42. What is the ratio of the Aid flow (current US$) in Niger in 2005 to that in 2011?
Your answer should be compact. 1.56. What is the ratio of the Aid flow (current US$) in Peru in 2005 to that in 2011?
Provide a short and direct response. 0.11. What is the ratio of the Aid flow (current US$) in Belarus in 2006 to that in 2007?
Offer a very short reply. 0.69. What is the ratio of the Aid flow (current US$) of Niger in 2006 to that in 2007?
Provide a short and direct response. 2.14. What is the ratio of the Aid flow (current US$) in Peru in 2006 to that in 2007?
Keep it short and to the point. 0.82. What is the ratio of the Aid flow (current US$) of Belarus in 2006 to that in 2008?
Offer a very short reply. 0.26. What is the ratio of the Aid flow (current US$) in Niger in 2006 to that in 2008?
Your answer should be compact. 1.06. What is the ratio of the Aid flow (current US$) in Peru in 2006 to that in 2008?
Give a very brief answer. 0.32. What is the ratio of the Aid flow (current US$) of Belarus in 2006 to that in 2009?
Your answer should be very brief. 0.41. What is the ratio of the Aid flow (current US$) of Niger in 2006 to that in 2009?
Ensure brevity in your answer.  1.42. What is the ratio of the Aid flow (current US$) in Peru in 2006 to that in 2009?
Keep it short and to the point. 0.37. What is the ratio of the Aid flow (current US$) of Belarus in 2006 to that in 2010?
Your answer should be compact. 0.69. What is the ratio of the Aid flow (current US$) in Niger in 2006 to that in 2010?
Provide a short and direct response. 1.78. What is the ratio of the Aid flow (current US$) in Peru in 2006 to that in 2010?
Offer a very short reply. 0.65. What is the ratio of the Aid flow (current US$) of Belarus in 2006 to that in 2011?
Your response must be concise. 0.75. What is the ratio of the Aid flow (current US$) of Niger in 2006 to that in 2011?
Your response must be concise. 10.33. What is the ratio of the Aid flow (current US$) of Peru in 2006 to that in 2011?
Provide a succinct answer. 0.32. What is the ratio of the Aid flow (current US$) in Belarus in 2007 to that in 2008?
Offer a terse response. 0.37. What is the ratio of the Aid flow (current US$) in Niger in 2007 to that in 2008?
Your response must be concise. 0.5. What is the ratio of the Aid flow (current US$) in Peru in 2007 to that in 2008?
Provide a short and direct response. 0.39. What is the ratio of the Aid flow (current US$) of Vietnam in 2007 to that in 2008?
Your response must be concise. 0.94. What is the ratio of the Aid flow (current US$) of Belarus in 2007 to that in 2009?
Provide a succinct answer. 0.59. What is the ratio of the Aid flow (current US$) in Niger in 2007 to that in 2009?
Your answer should be compact. 0.67. What is the ratio of the Aid flow (current US$) of Peru in 2007 to that in 2009?
Your answer should be compact. 0.45. What is the ratio of the Aid flow (current US$) of Vietnam in 2007 to that in 2009?
Provide a short and direct response. 5.14. What is the ratio of the Aid flow (current US$) in Belarus in 2007 to that in 2010?
Keep it short and to the point. 1. What is the ratio of the Aid flow (current US$) of Niger in 2007 to that in 2010?
Give a very brief answer. 0.83. What is the ratio of the Aid flow (current US$) in Peru in 2007 to that in 2010?
Give a very brief answer. 0.8. What is the ratio of the Aid flow (current US$) of Vietnam in 2007 to that in 2010?
Give a very brief answer. 1.07. What is the ratio of the Aid flow (current US$) in Belarus in 2007 to that in 2011?
Keep it short and to the point. 1.08. What is the ratio of the Aid flow (current US$) of Niger in 2007 to that in 2011?
Your answer should be compact. 4.83. What is the ratio of the Aid flow (current US$) of Peru in 2007 to that in 2011?
Ensure brevity in your answer.  0.39. What is the ratio of the Aid flow (current US$) in Vietnam in 2007 to that in 2011?
Make the answer very short. 1.53. What is the ratio of the Aid flow (current US$) of Belarus in 2008 to that in 2009?
Your answer should be compact. 1.59. What is the ratio of the Aid flow (current US$) in Niger in 2008 to that in 2009?
Make the answer very short. 1.34. What is the ratio of the Aid flow (current US$) in Peru in 2008 to that in 2009?
Make the answer very short. 1.15. What is the ratio of the Aid flow (current US$) of Vietnam in 2008 to that in 2009?
Provide a short and direct response. 5.46. What is the ratio of the Aid flow (current US$) of Belarus in 2008 to that in 2010?
Give a very brief answer. 2.69. What is the ratio of the Aid flow (current US$) of Niger in 2008 to that in 2010?
Offer a terse response. 1.67. What is the ratio of the Aid flow (current US$) of Peru in 2008 to that in 2010?
Offer a very short reply. 2.02. What is the ratio of the Aid flow (current US$) of Vietnam in 2008 to that in 2010?
Give a very brief answer. 1.13. What is the ratio of the Aid flow (current US$) in Belarus in 2008 to that in 2011?
Give a very brief answer. 2.92. What is the ratio of the Aid flow (current US$) in Niger in 2008 to that in 2011?
Give a very brief answer. 9.71. What is the ratio of the Aid flow (current US$) in Peru in 2008 to that in 2011?
Provide a succinct answer. 0.98. What is the ratio of the Aid flow (current US$) of Vietnam in 2008 to that in 2011?
Your answer should be compact. 1.62. What is the ratio of the Aid flow (current US$) in Belarus in 2009 to that in 2010?
Offer a very short reply. 1.69. What is the ratio of the Aid flow (current US$) of Niger in 2009 to that in 2010?
Ensure brevity in your answer.  1.25. What is the ratio of the Aid flow (current US$) of Peru in 2009 to that in 2010?
Provide a succinct answer. 1.76. What is the ratio of the Aid flow (current US$) in Vietnam in 2009 to that in 2010?
Provide a succinct answer. 0.21. What is the ratio of the Aid flow (current US$) of Belarus in 2009 to that in 2011?
Provide a short and direct response. 1.83. What is the ratio of the Aid flow (current US$) in Niger in 2009 to that in 2011?
Make the answer very short. 7.25. What is the ratio of the Aid flow (current US$) of Peru in 2009 to that in 2011?
Provide a succinct answer. 0.86. What is the ratio of the Aid flow (current US$) in Vietnam in 2009 to that in 2011?
Your answer should be very brief. 0.3. What is the ratio of the Aid flow (current US$) in Belarus in 2010 to that in 2011?
Your response must be concise. 1.08. What is the ratio of the Aid flow (current US$) in Niger in 2010 to that in 2011?
Make the answer very short. 5.81. What is the ratio of the Aid flow (current US$) in Peru in 2010 to that in 2011?
Keep it short and to the point. 0.49. What is the ratio of the Aid flow (current US$) of Vietnam in 2010 to that in 2011?
Give a very brief answer. 1.43. What is the difference between the highest and the second highest Aid flow (current US$) of Niger?
Keep it short and to the point. 3.20e+05. What is the difference between the highest and the lowest Aid flow (current US$) of Niger?
Your answer should be compact. 4.85e+06. What is the difference between the highest and the lowest Aid flow (current US$) of Peru?
Your answer should be very brief. 9.59e+06. What is the difference between the highest and the lowest Aid flow (current US$) of Vietnam?
Keep it short and to the point. 6.44e+06. 